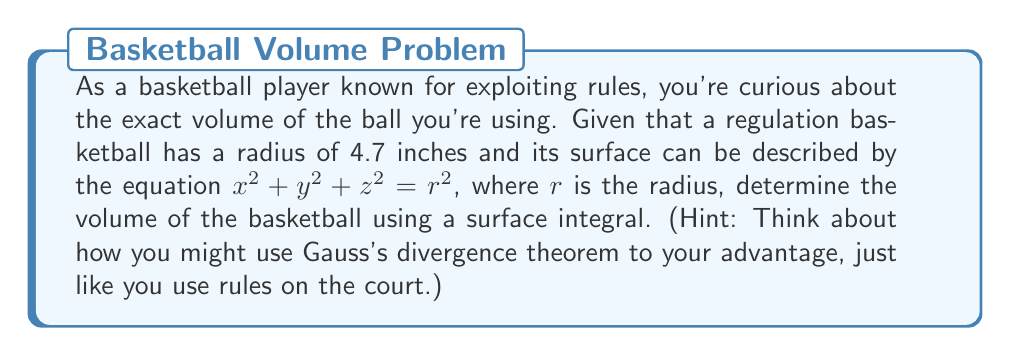Show me your answer to this math problem. Let's approach this step-by-step:

1) We'll use Gauss's divergence theorem, which states:

   $$\iiint_V \nabla \cdot \mathbf{F} \, dV = \oiint_S \mathbf{F} \cdot \mathbf{n} \, dS$$

   where $V$ is the volume, $S$ is the surface, and $\mathbf{n}$ is the outward unit normal vector.

2) We need to choose an $\mathbf{F}$ such that $\nabla \cdot \mathbf{F} = 1$. A simple choice is $\mathbf{F} = \frac{1}{3}(x, y, z)$.

3) The outward unit normal vector for a sphere is $\mathbf{n} = \frac{1}{r}(x, y, z)$.

4) Now, we can set up our surface integral:

   $$V = \iiint_V 1 \, dV = \iiint_V \nabla \cdot \mathbf{F} \, dV = \oiint_S \mathbf{F} \cdot \mathbf{n} \, dS$$

5) Substituting our $\mathbf{F}$ and $\mathbf{n}$:

   $$V = \oiint_S \frac{1}{3}(x, y, z) \cdot \frac{1}{r}(x, y, z) \, dS = \frac{1}{3r} \oiint_S (x^2 + y^2 + z^2) \, dS$$

6) On the surface of the sphere, $x^2 + y^2 + z^2 = r^2$, so:

   $$V = \frac{1}{3r} \oiint_S r^2 \, dS = \frac{r}{3} \oiint_S dS$$

7) The surface area of a sphere is $4\pi r^2$, so:

   $$V = \frac{r}{3} \cdot 4\pi r^2 = \frac{4\pi r^3}{3}$$

8) Finally, substituting $r = 4.7$ inches:

   $$V = \frac{4\pi (4.7 \text{ in})^3}{3} \approx 434.89 \text{ cubic inches}$$
Answer: $\frac{4\pi r^3}{3} \approx 434.89 \text{ in}^3$ 